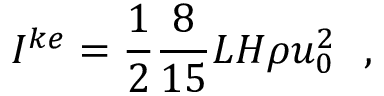Convert formula to latex. <formula><loc_0><loc_0><loc_500><loc_500>I ^ { k e } = { \frac { 1 } { 2 } } { \frac { 8 } { 1 5 } } L H \rho u _ { 0 } ^ { 2 } ,</formula> 